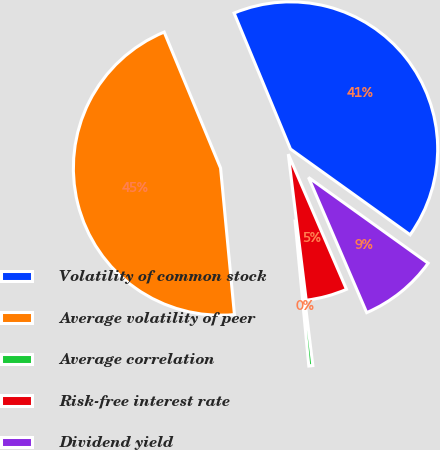<chart> <loc_0><loc_0><loc_500><loc_500><pie_chart><fcel>Volatility of common stock<fcel>Average volatility of peer<fcel>Average correlation<fcel>Risk-free interest rate<fcel>Dividend yield<nl><fcel>41.16%<fcel>45.25%<fcel>0.44%<fcel>4.53%<fcel>8.63%<nl></chart> 